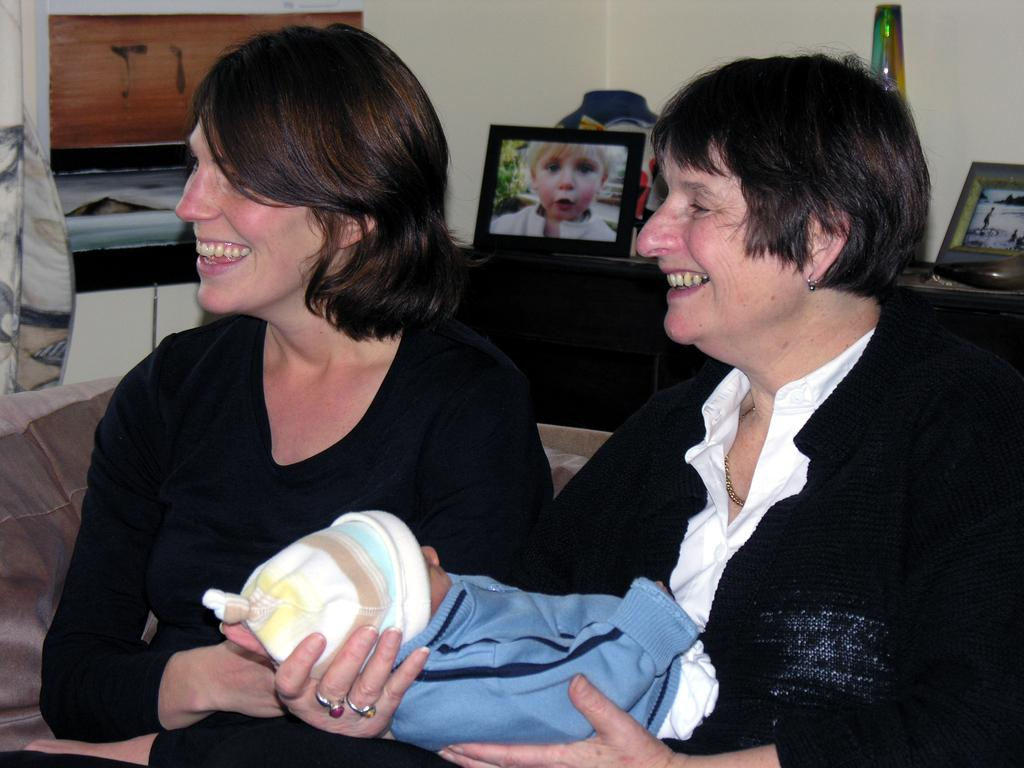How many people are smiling in the image? There are two people smiling in the image. What is the person in the image doing with the baby? The person is holding the baby in the image. Can you describe any objects visible in the image? There are objects visible in the image, but their specific details are not mentioned in the facts. What type of structure can be seen in the image? There is a wall visible in the image. What type of pin is being used to hold the baby's clothes in the image? There is no pin visible in the image, and the baby's clothes are not mentioned in the facts. What design can be seen on the wall in the image? The design on the wall is not mentioned in the facts, so it cannot be described. 